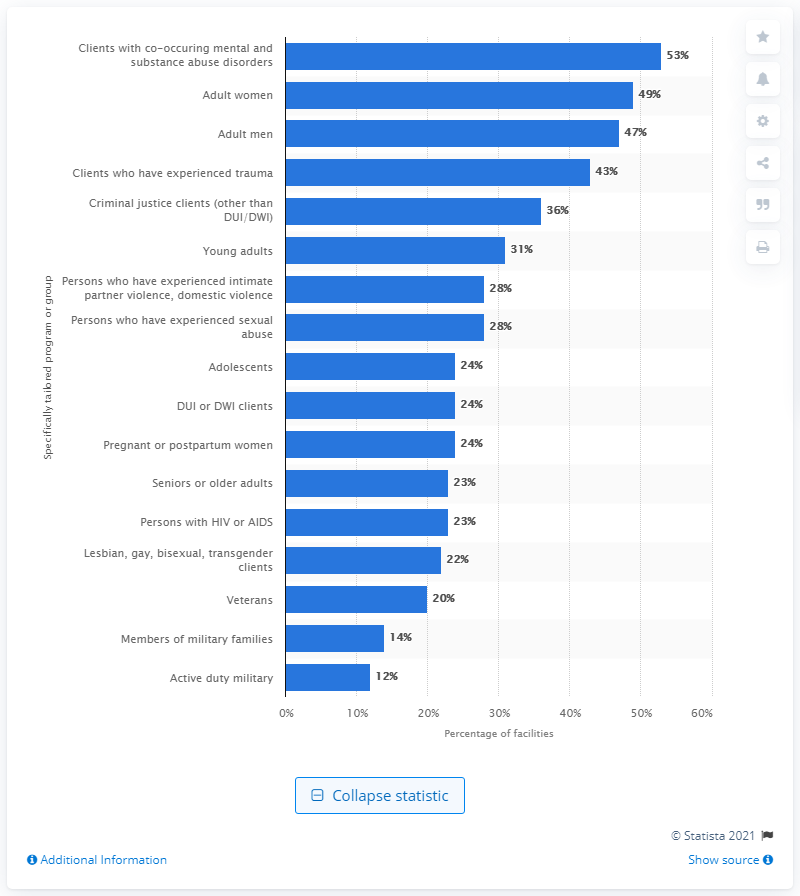Identify some key points in this picture. According to recent data, a significant 23% of the country's substance abuse treatment facilities provide programs specifically designed for seniors or older adults. 